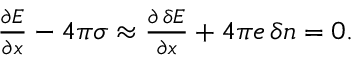Convert formula to latex. <formula><loc_0><loc_0><loc_500><loc_500>\begin{array} { r } { \frac { \partial E } { \partial x } - 4 \pi \sigma \approx \frac { \partial \, \delta E } { \partial x } + 4 \pi e \, \delta n = 0 . } \end{array}</formula> 